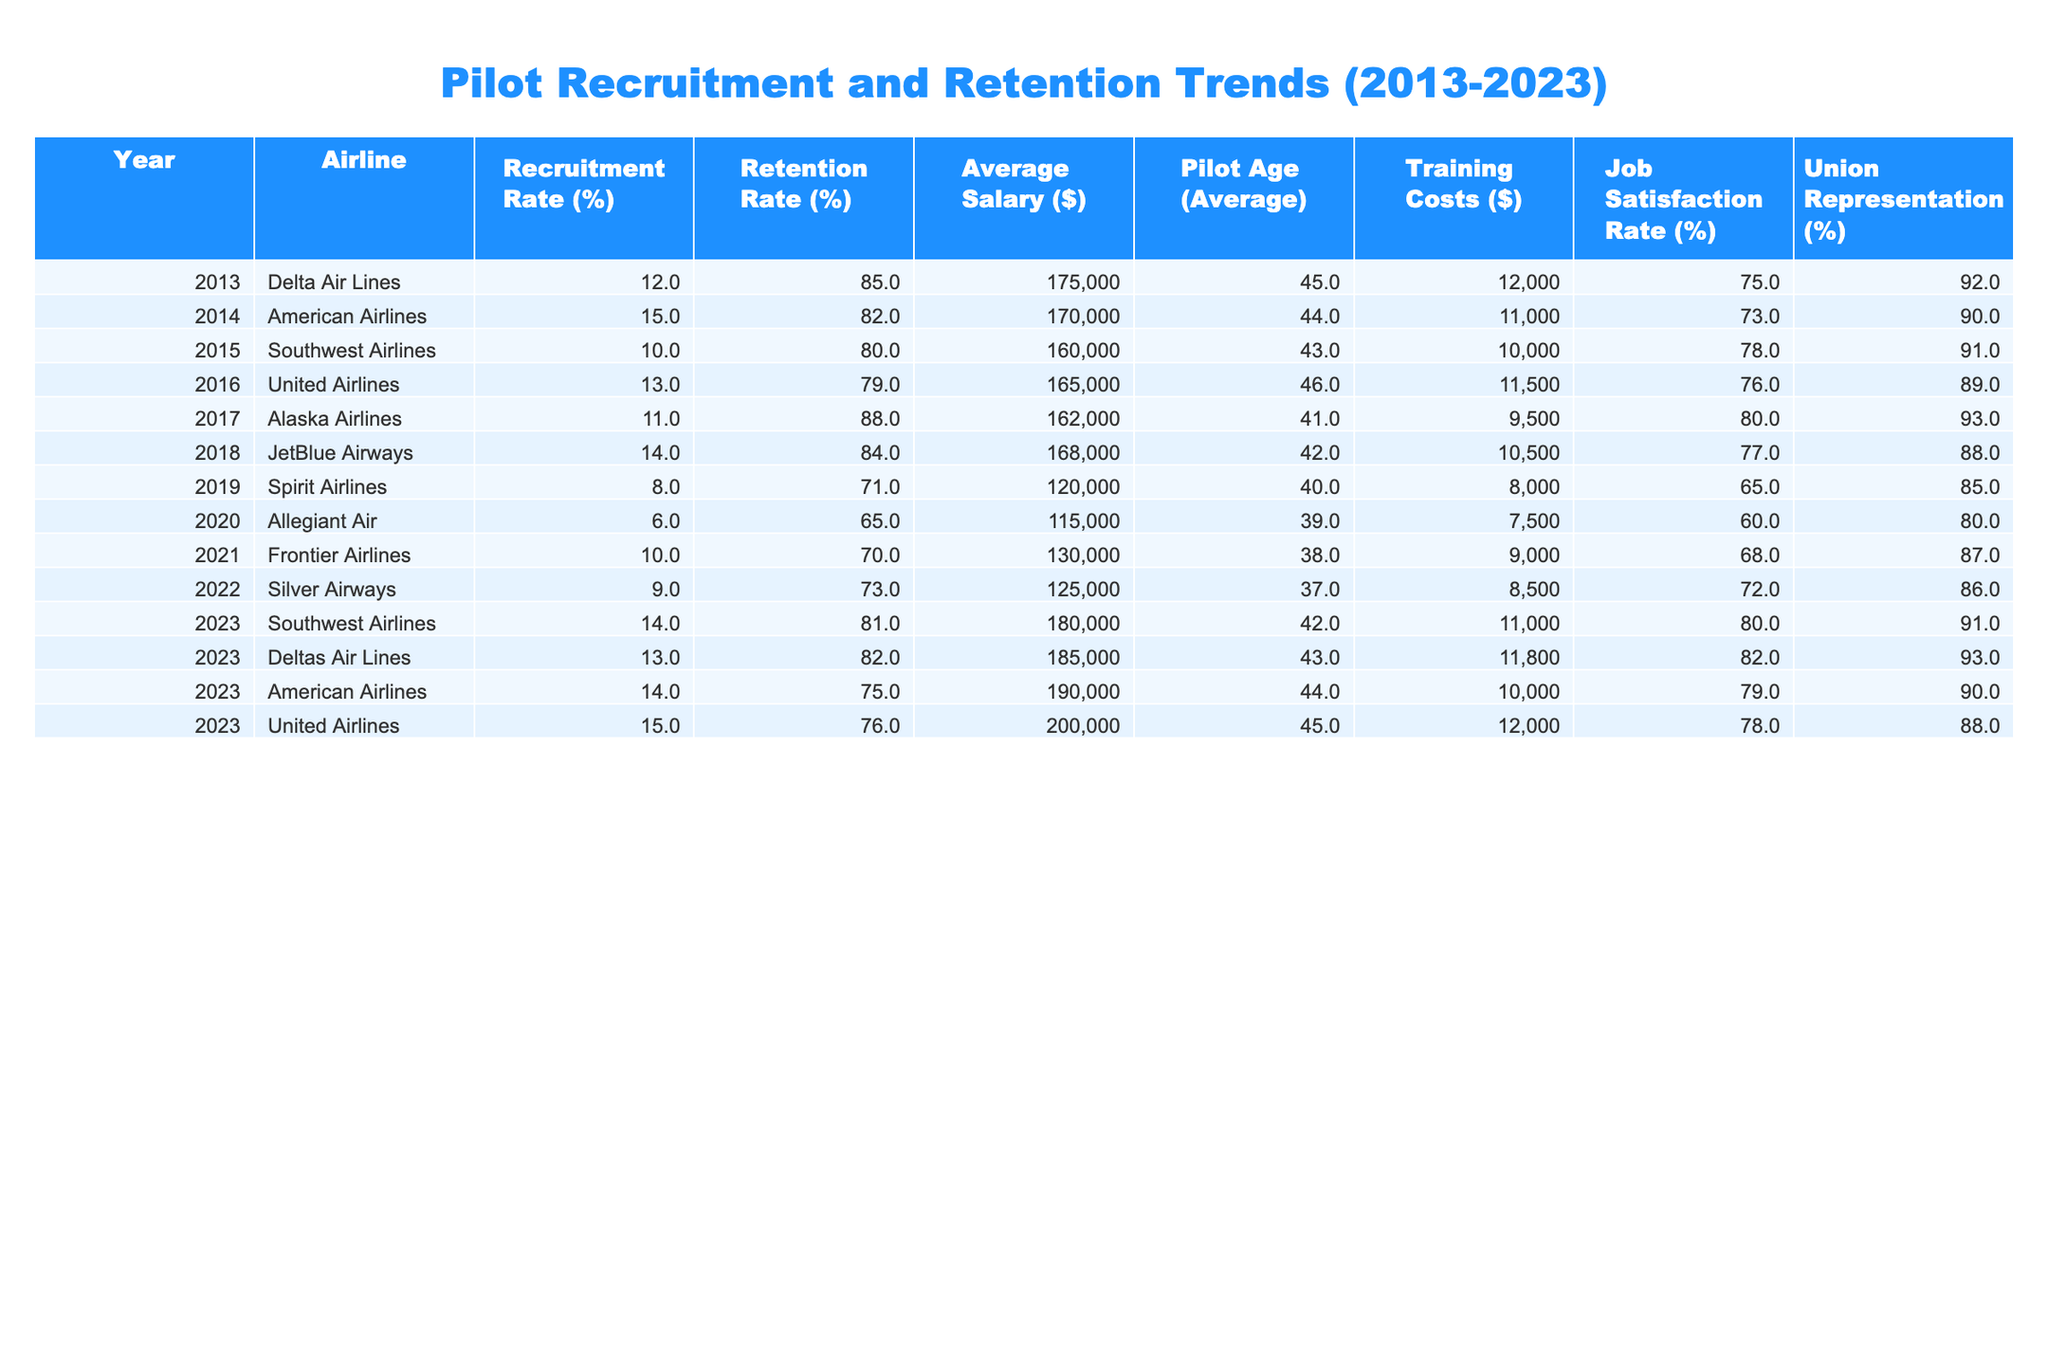What was the recruitment rate for United Airlines in 2021? The table shows that United Airlines had a recruitment rate of 10% in 2021.
Answer: 10% Which airline had the highest retention rate in 2017? By checking the retention rates in the table, Alaska Airlines had the highest retention rate at 88% in 2017.
Answer: Alaska Airlines What was the average pilot age across all airlines in 2023? To find the average pilot age in 2023, sum the ages (42 + 43 + 44 + 45 = 174) and divide by the number of airlines (4), yielding an average of 174/4 = 43.5.
Answer: 43.5 Did the recruitment rate increase for Southwest Airlines from 2018 to 2023? In 2018, Southwest Airlines had a recruitment rate of 14% and in 2023 the rate increased to 14%, displaying no change.
Answer: No What is the difference in average salary between the airlines with the highest and lowest recruitment rates in 2013? In 2013, Delta had a recruitment rate of 12% with an average salary of $175,000, while Southwest had a staff recruitment rate of 10% with a salary of $160,000, creating a difference of $175,000 - $160,000 = $15,000.
Answer: $15,000 Which airline had the lowest job satisfaction rate, and what was that rate? Looking through the table, Spirit Airlines had the lowest job satisfaction rate at 65%.
Answer: Spirit Airlines, 65% Has the training cost for pilots increased or decreased from 2013 to 2023? In 2013, training costs were $12,000 and in 2023, it was $11,000, indicating a decrease of $1,000.
Answer: Decreased What is the overall trend of recruitment rates from 2013 to 2023? By examining the table, the recruitment rates show fluctuating trends without a clear upward trajectory, but there is an increase noted towards 2023.
Answer: Fluctuating with an increase towards 2023 What percentage of pilots were represented by unions on average during the last decade (2013-2023)? To find the average percentage of union representation, sum the percentages (92 + 90 + 91 + 89 + 93 + 88 + 85 + 80 + 87 + 86 + 91 + 93 + 90 + 88) and divide by the number of values (14), which equals roughly 88.4%.
Answer: 88.4% Did average salaries increase for pilots between 2019 and 2023? In 2019, the average salary was $120,000, and by 2023, it increased to $200,000, confirming that average salaries increased significantly.
Answer: Yes 